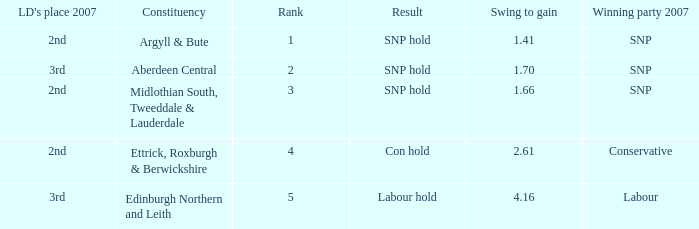What is the constituency when the rank is less than 5 and the result is con hold? Ettrick, Roxburgh & Berwickshire. 